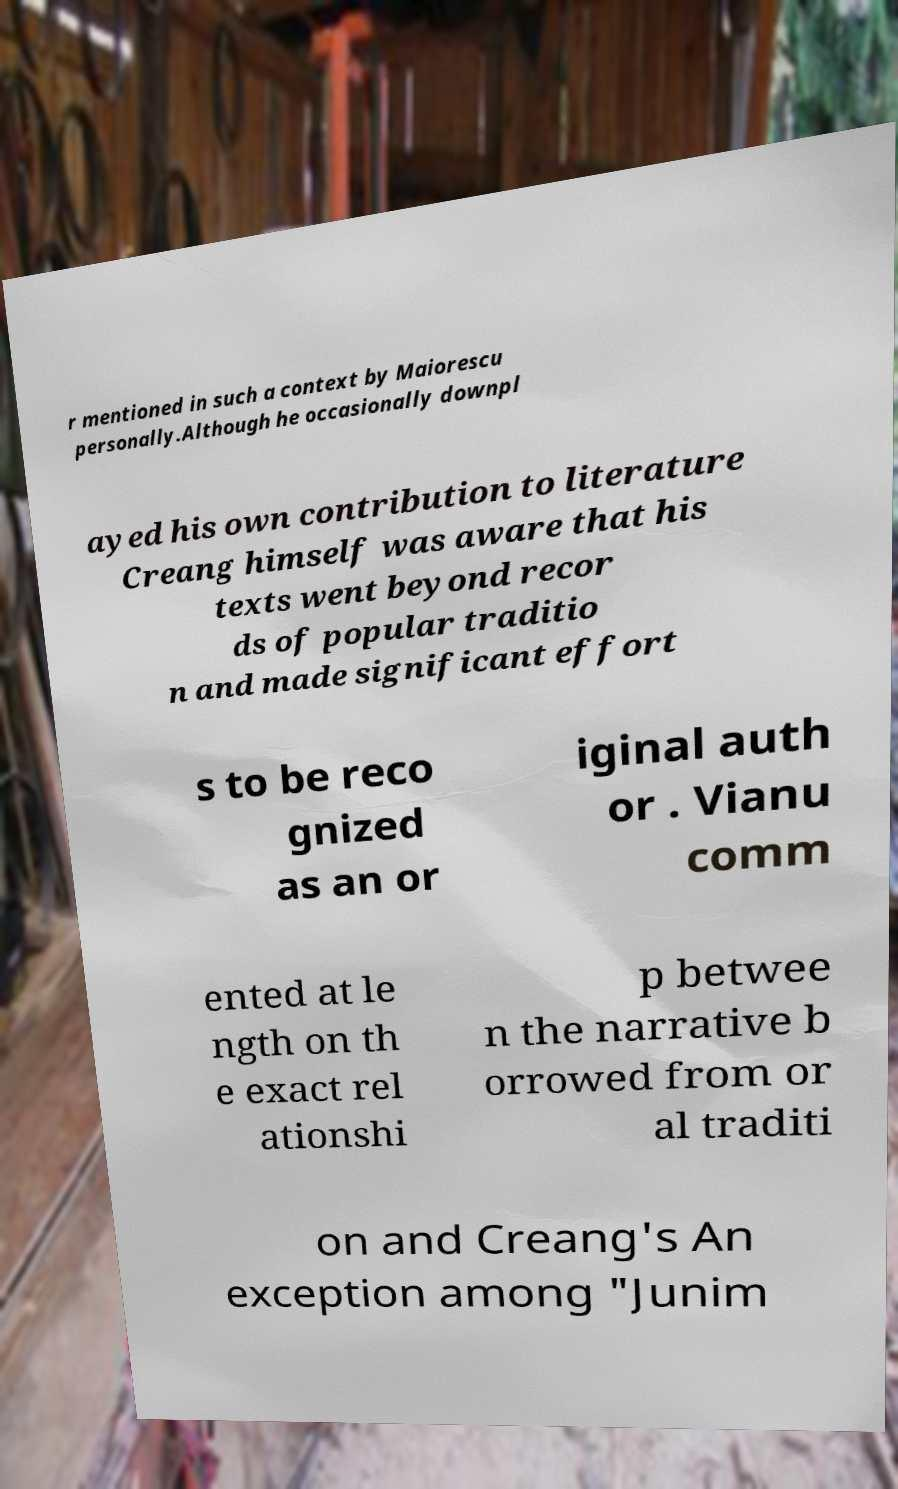Can you accurately transcribe the text from the provided image for me? r mentioned in such a context by Maiorescu personally.Although he occasionally downpl ayed his own contribution to literature Creang himself was aware that his texts went beyond recor ds of popular traditio n and made significant effort s to be reco gnized as an or iginal auth or . Vianu comm ented at le ngth on th e exact rel ationshi p betwee n the narrative b orrowed from or al traditi on and Creang's An exception among "Junim 